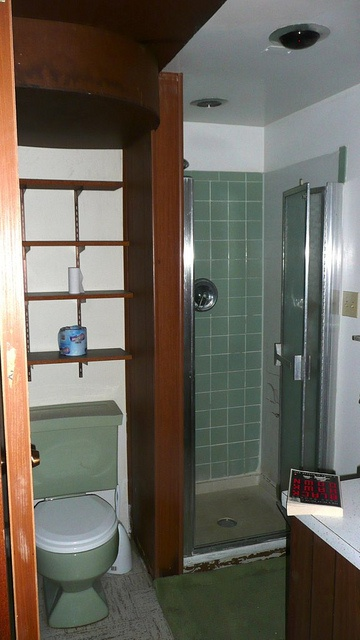Describe the objects in this image and their specific colors. I can see toilet in tan, gray, and darkgray tones and book in tan, black, ivory, maroon, and gray tones in this image. 